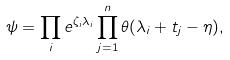<formula> <loc_0><loc_0><loc_500><loc_500>\psi = \prod _ { i } e ^ { \zeta _ { i } \lambda _ { i } } \prod _ { j = 1 } ^ { n } \theta ( \lambda _ { i } + t _ { j } - \eta ) ,</formula> 